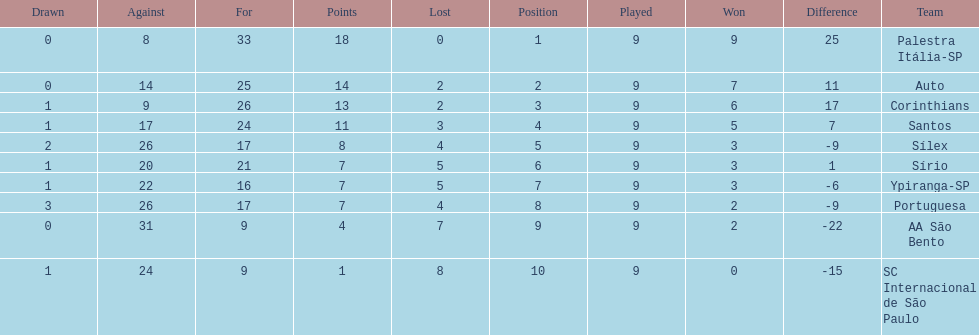Which team was the top scoring team? Palestra Itália-SP. 